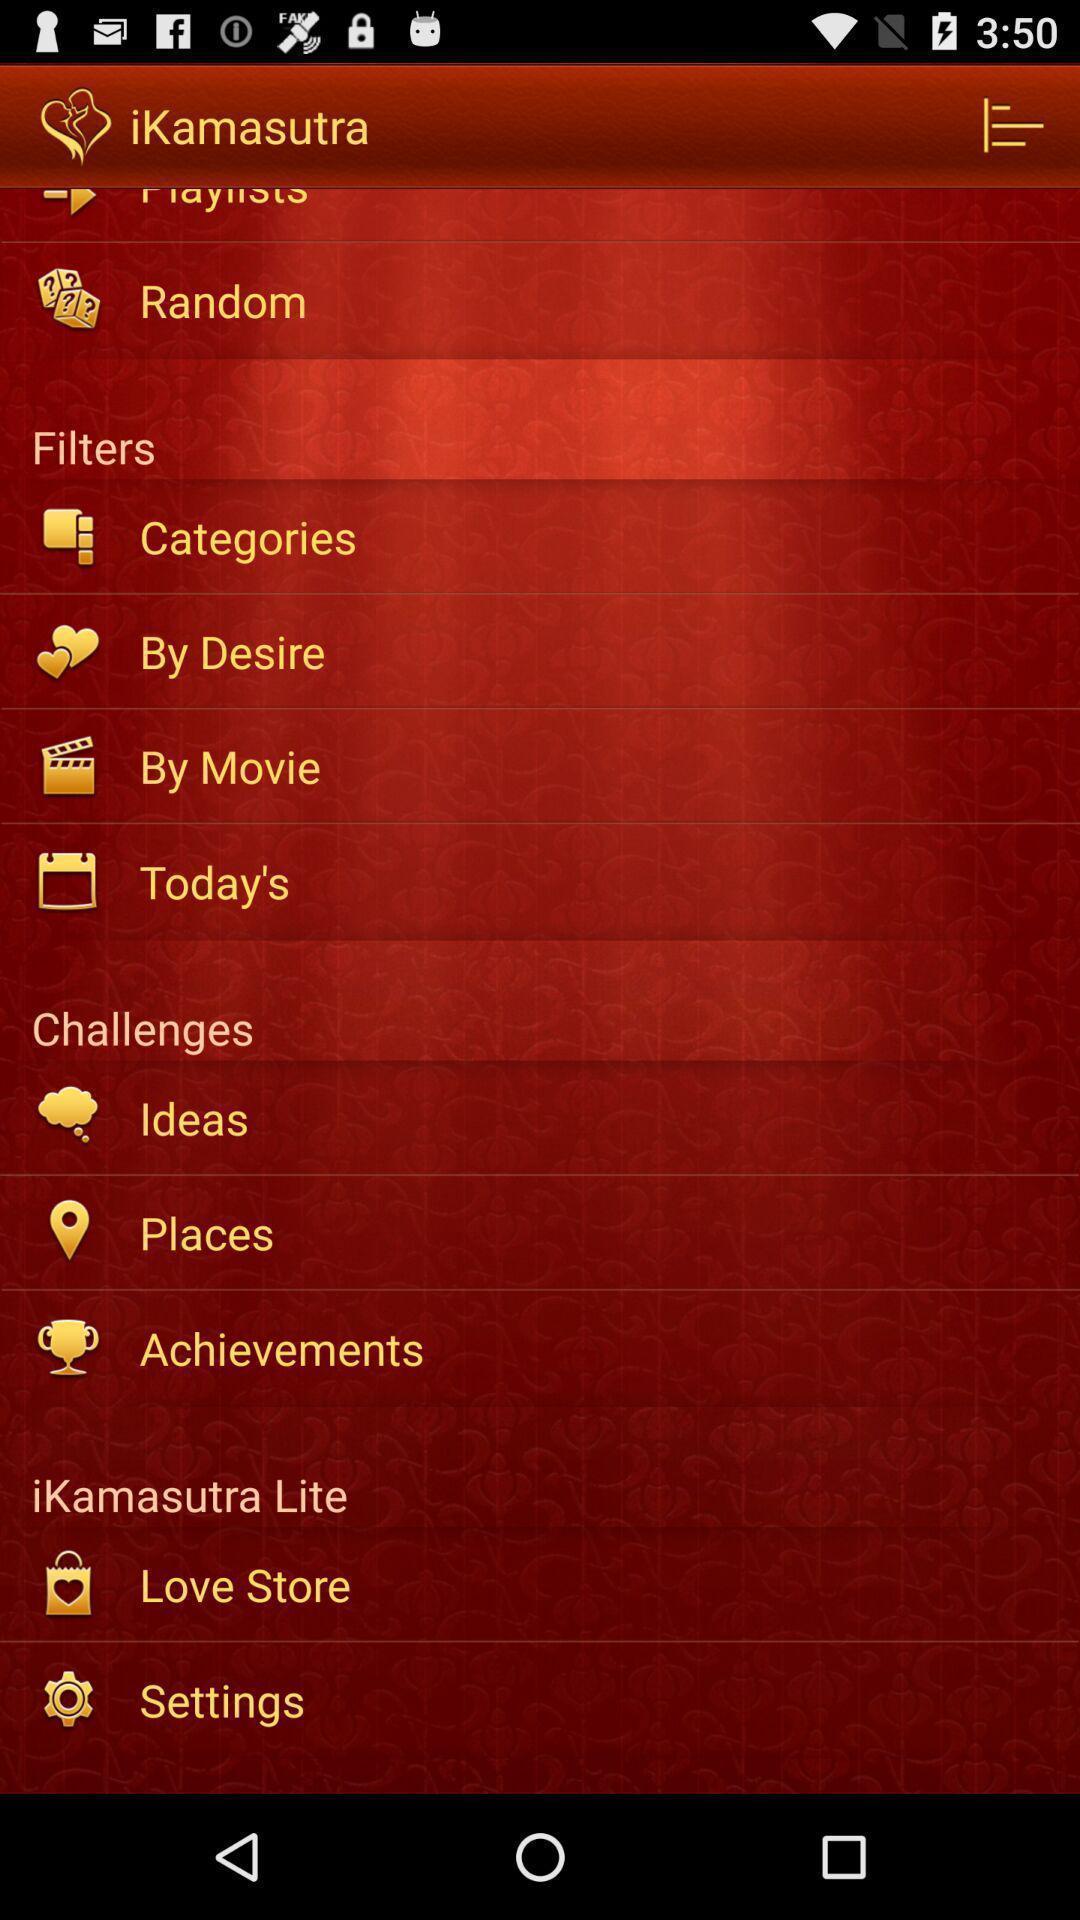Describe the visual elements of this screenshot. Screen shows multiple options. 